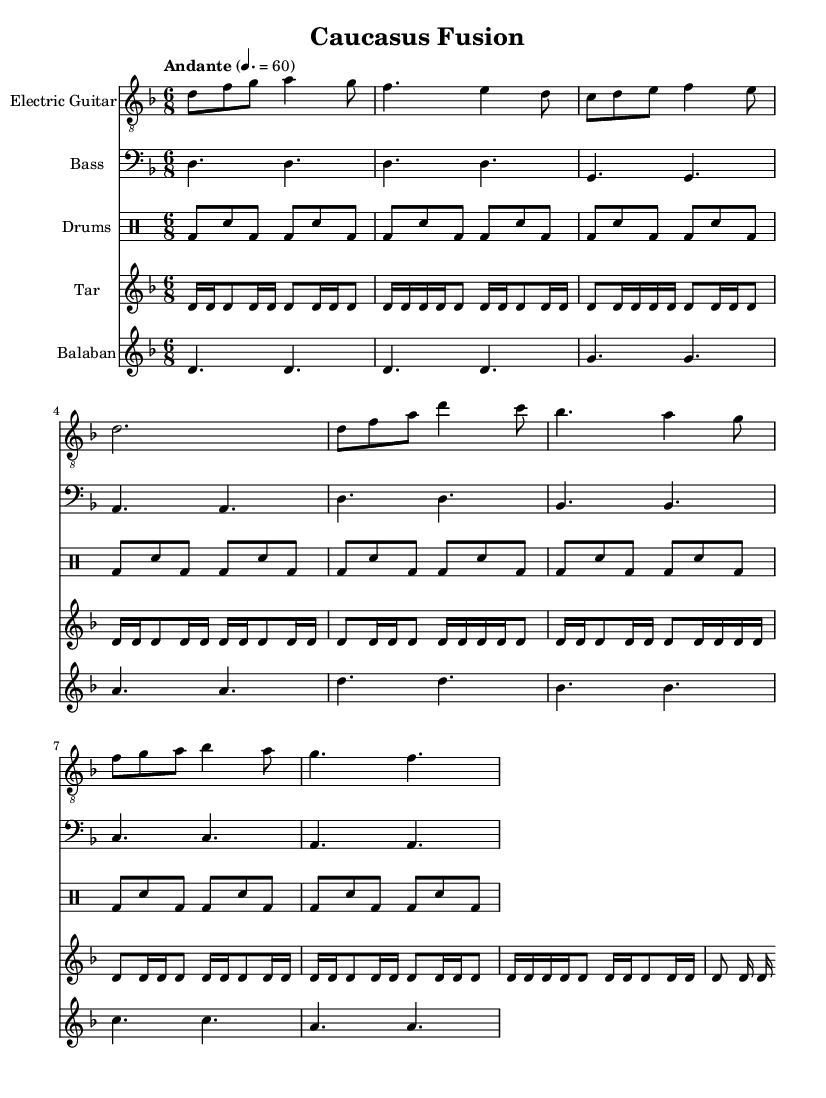What is the key signature of this music? The key signature is indicated at the beginning of the staff. It shows one flat, which corresponds to D minor.
Answer: D minor What is the time signature of this music? The time signature is specified at the beginning of the sheet music, indicating that there are six beats in each measure. This is denoted by the 6 over 8.
Answer: 6/8 What is the tempo marking for this piece? The tempo marking is indicated in a specific font above the staff, stating "Andante" with a metronome marking of 60 beats per minute.
Answer: Andante How many measures does the electric guitar part have? To find the number of measures, we count each segment separated by vertical lines in the electric guitar part. There are 8 measures total.
Answer: 8 What instruments are part of this fusion composition? By examining the scored parts listed, we can identify that the composition includes Electric Guitar, Bass, Drums, Tar, and Balaban.
Answer: Electric Guitar, Bass, Drums, Tar, Balaban What is the rhythmic pattern used in the drums part? The drums part shows a repeating pattern throughout, consisting primarily of bass drum (bd) and snare (sn) hits in eighth notes. This indicates a consistent rhythm across measures.
Answer: Eighth notes What traditional instrument is represented by the tar part? The tar is a traditional Azerbaijani string instrument, and its part is specifically notated in the sheet music. It can be identified by its name in the staff header.
Answer: Tar 